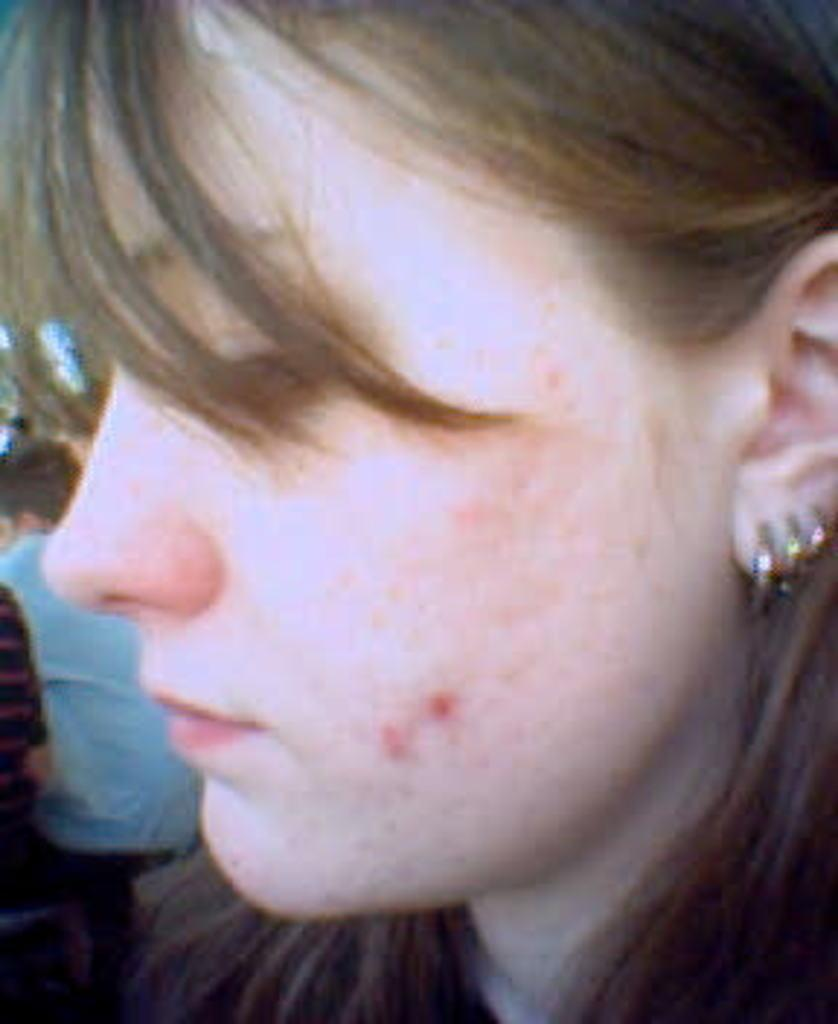What is the main subject of the image? There is a woman's face in the image. What can be observed on the woman's face? The woman has pimples on her face. What type of accessory is the woman wearing? The woman is wearing earrings. Can you describe the presence of another person in the image? There is a person standing behind the woman in the image. What type of gun is the woman holding in the image? There is no gun present in the image; it only features a woman's face and a person standing behind her. How does the woman's digestion appear to be in the image? There is no information about the woman's digestion in the image, as it only shows her face and the presence of another person. 